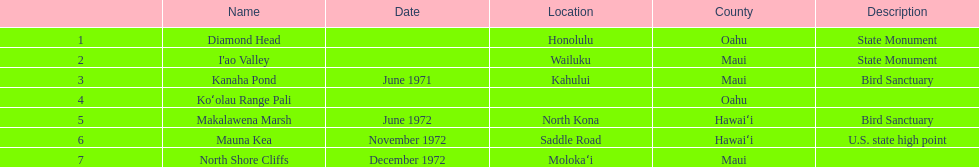What is the total number of state monuments? 2. 